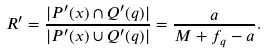Convert formula to latex. <formula><loc_0><loc_0><loc_500><loc_500>R ^ { \prime } = \frac { | P ^ { \prime } ( x ) \cap Q ^ { \prime } ( q ) | } { | P ^ { \prime } ( x ) \cup Q ^ { \prime } ( q ) | } = \frac { a } { M + f _ { q } - a } .</formula> 